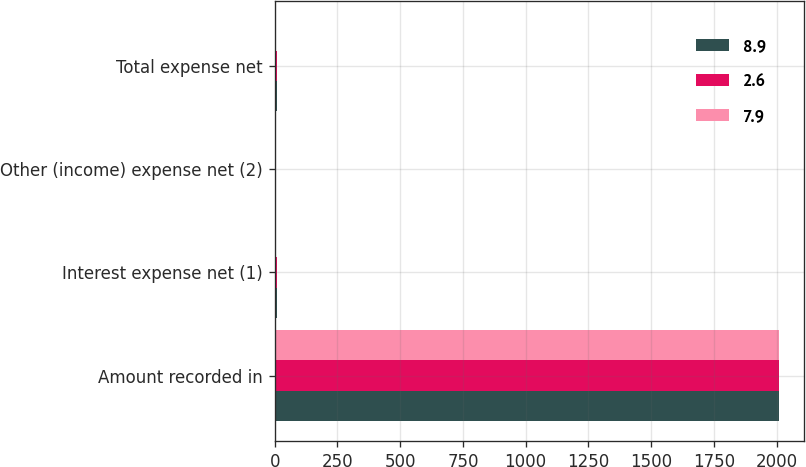Convert chart to OTSL. <chart><loc_0><loc_0><loc_500><loc_500><stacked_bar_chart><ecel><fcel>Amount recorded in<fcel>Interest expense net (1)<fcel>Other (income) expense net (2)<fcel>Total expense net<nl><fcel>8.9<fcel>2010<fcel>10.7<fcel>2.8<fcel>7.9<nl><fcel>2.6<fcel>2009<fcel>9.6<fcel>0.7<fcel>8.9<nl><fcel>7.9<fcel>2008<fcel>2<fcel>0.6<fcel>2.6<nl></chart> 